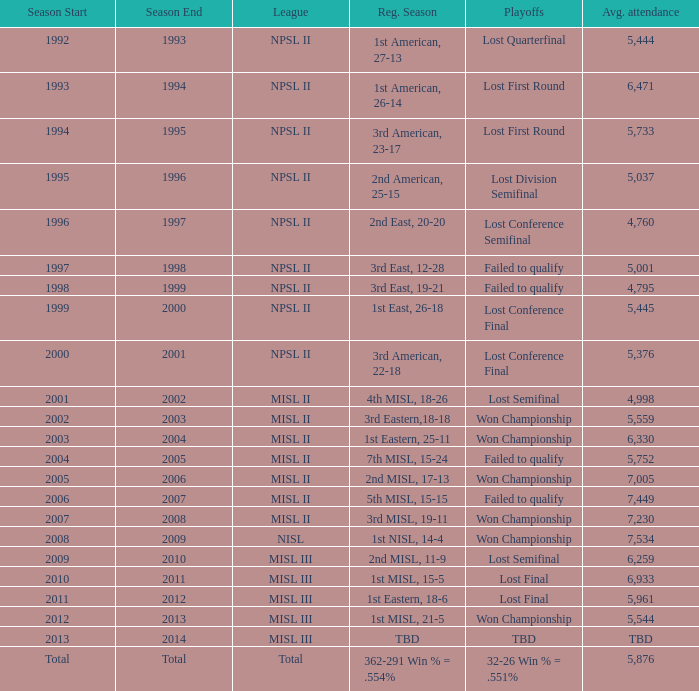When was the year that had an average attendance of 5,445? 1999-00. 